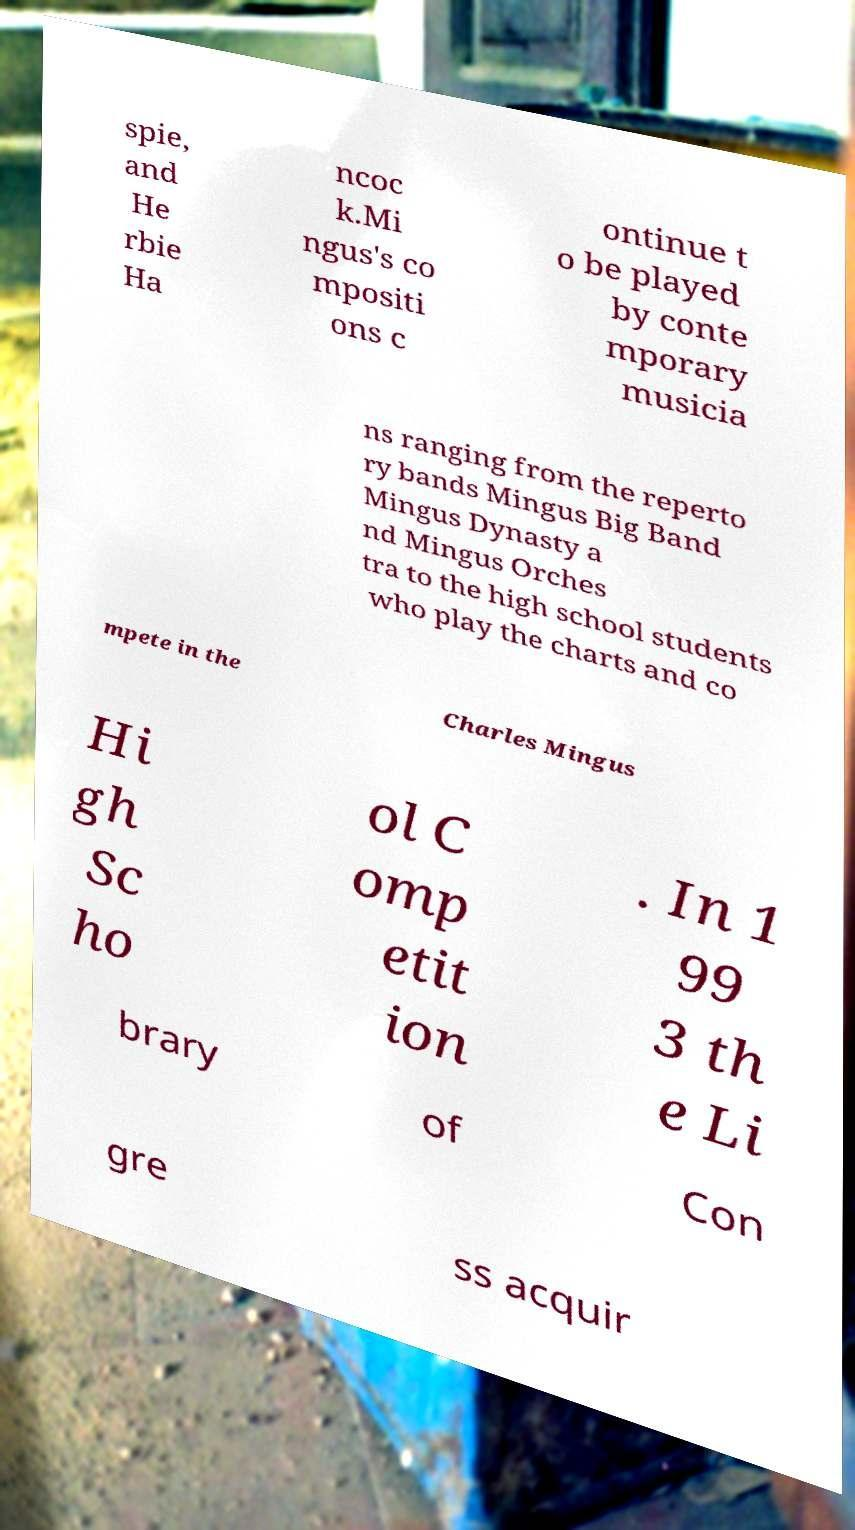Could you assist in decoding the text presented in this image and type it out clearly? spie, and He rbie Ha ncoc k.Mi ngus's co mpositi ons c ontinue t o be played by conte mporary musicia ns ranging from the reperto ry bands Mingus Big Band Mingus Dynasty a nd Mingus Orches tra to the high school students who play the charts and co mpete in the Charles Mingus Hi gh Sc ho ol C omp etit ion . In 1 99 3 th e Li brary of Con gre ss acquir 